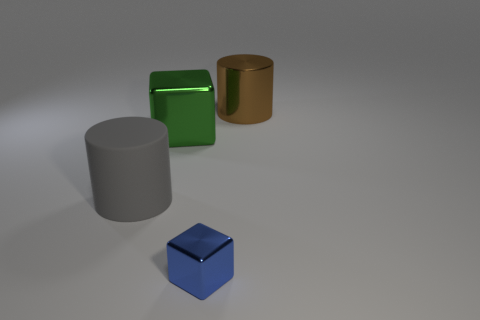Add 3 big blue blocks. How many objects exist? 7 Subtract all tiny green objects. Subtract all big brown metal cylinders. How many objects are left? 3 Add 3 blue objects. How many blue objects are left? 4 Add 2 tiny blue things. How many tiny blue things exist? 3 Subtract 0 brown balls. How many objects are left? 4 